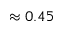Convert formula to latex. <formula><loc_0><loc_0><loc_500><loc_500>\approx 0 . 4 5</formula> 